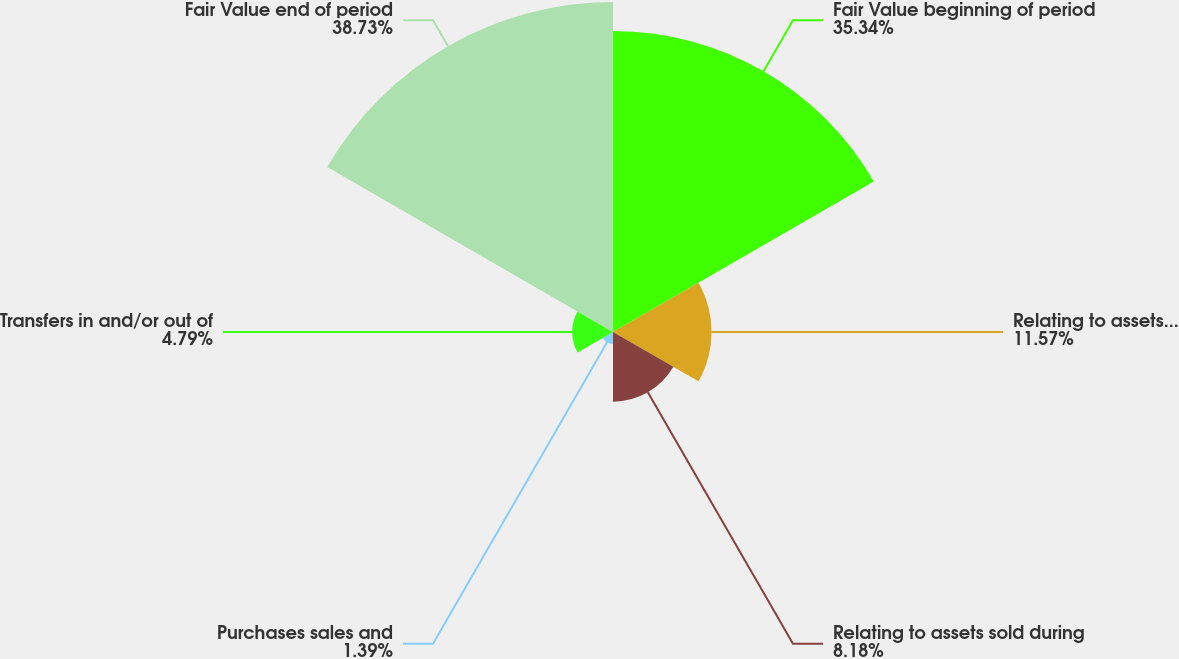<chart> <loc_0><loc_0><loc_500><loc_500><pie_chart><fcel>Fair Value beginning of period<fcel>Relating to assets still held<fcel>Relating to assets sold during<fcel>Purchases sales and<fcel>Transfers in and/or out of<fcel>Fair Value end of period<nl><fcel>35.34%<fcel>11.57%<fcel>8.18%<fcel>1.39%<fcel>4.79%<fcel>38.73%<nl></chart> 